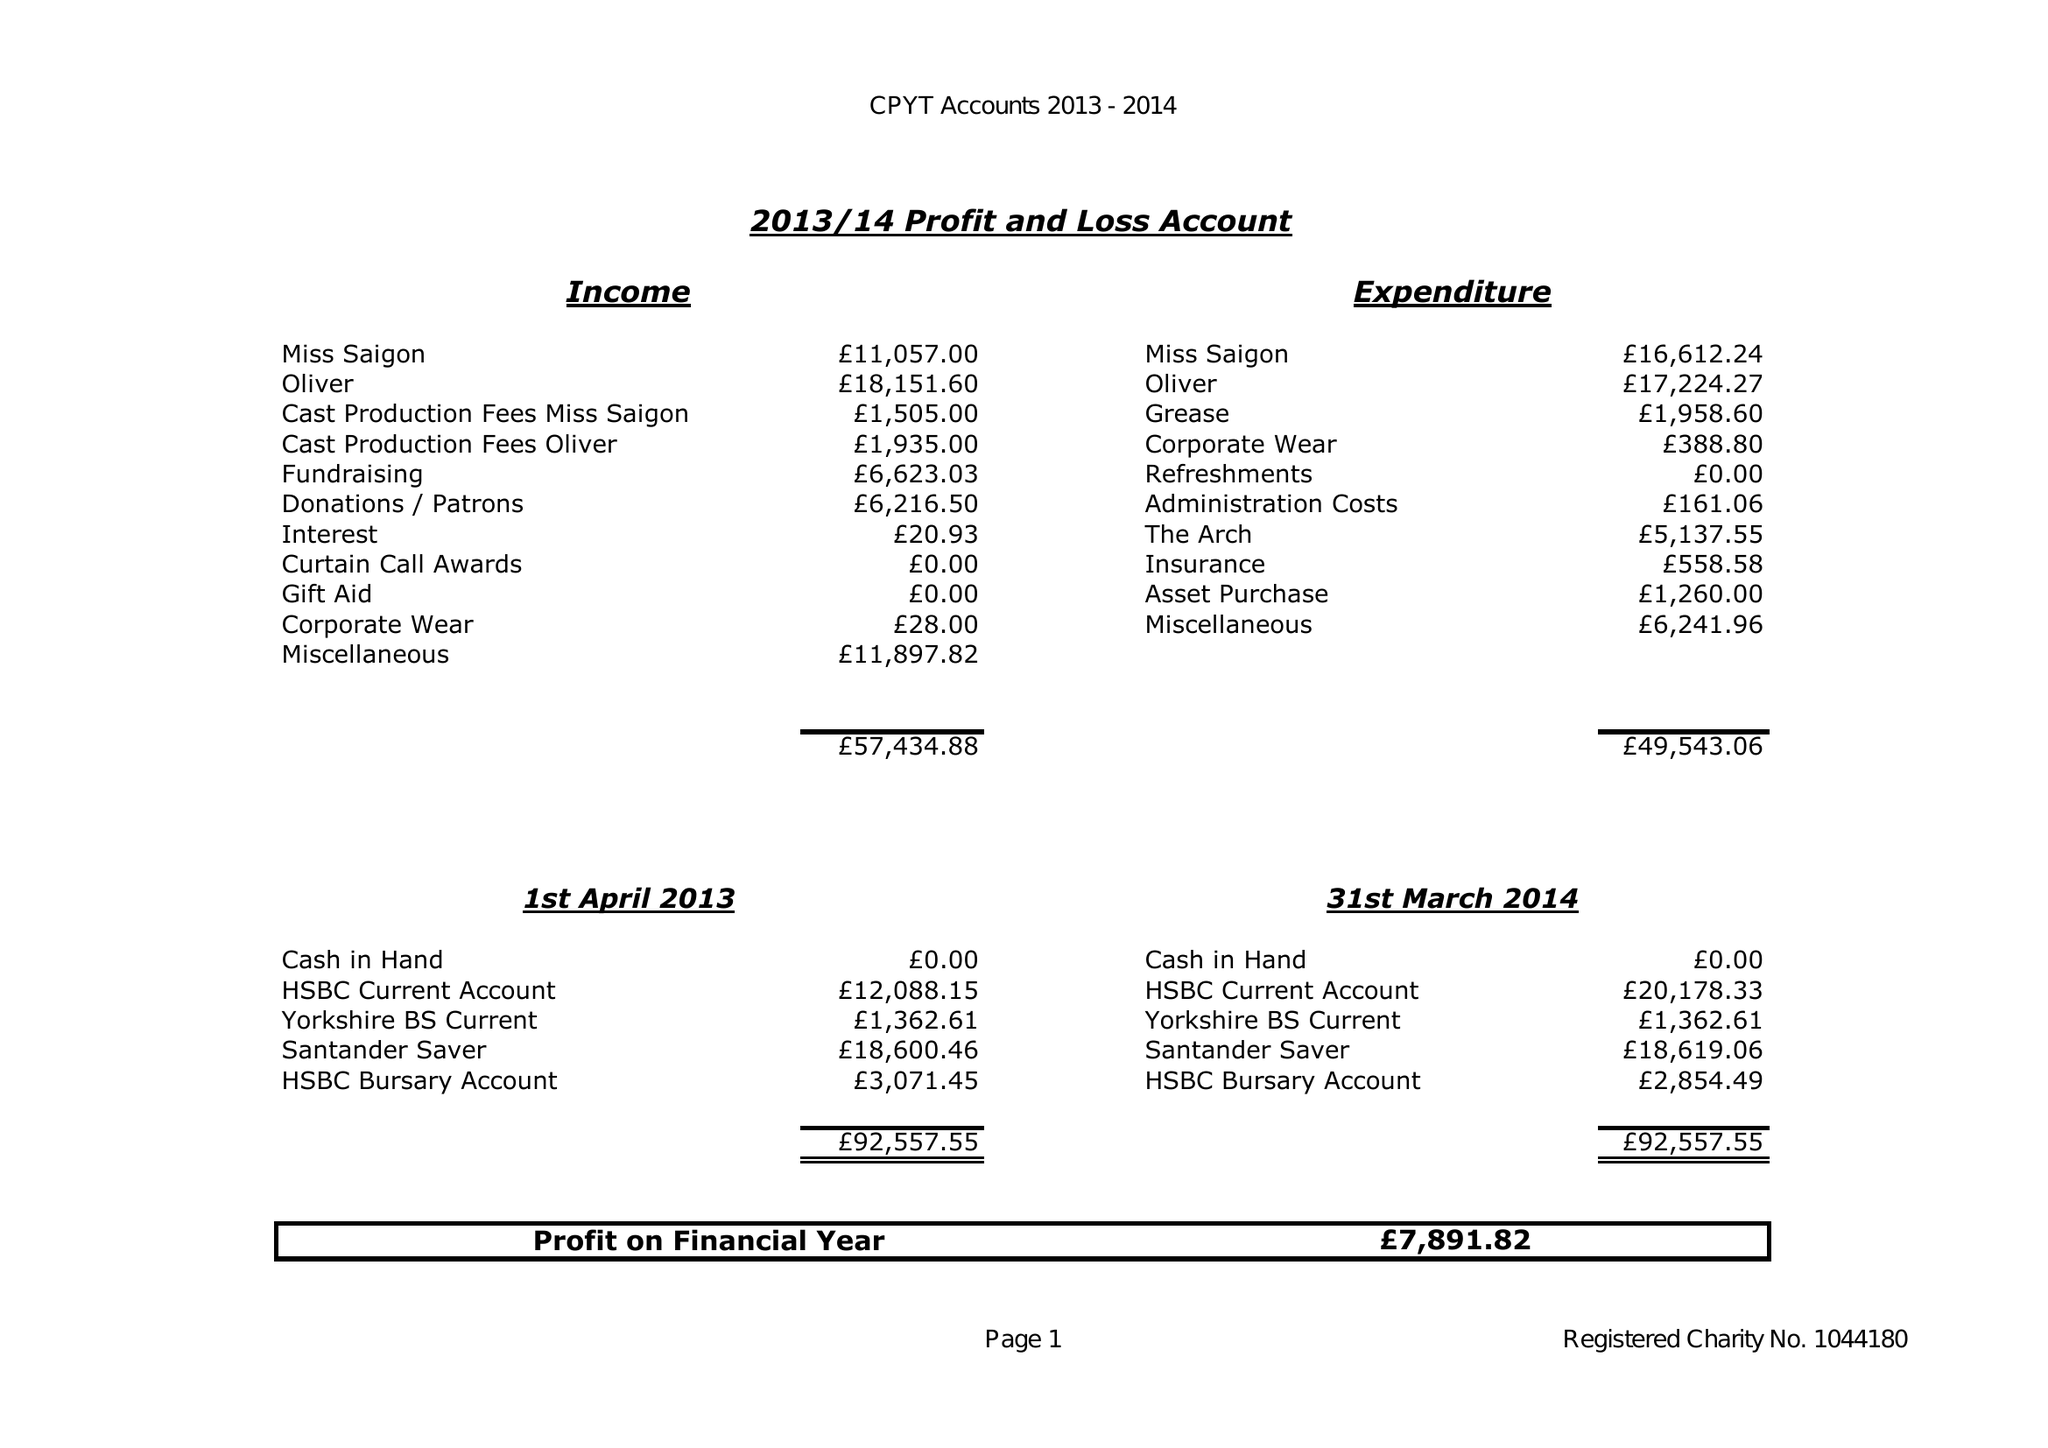What is the value for the address__postcode?
Answer the question using a single word or phrase. SO18 3ND 